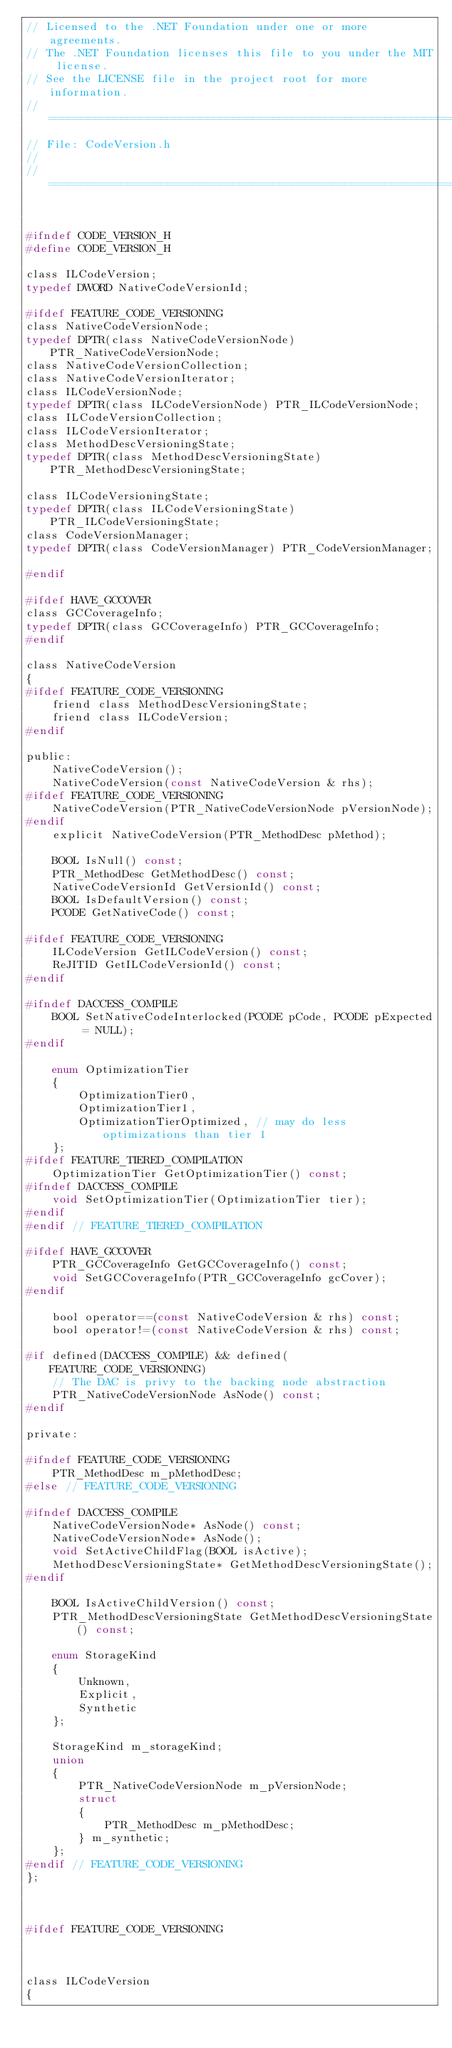<code> <loc_0><loc_0><loc_500><loc_500><_C_>// Licensed to the .NET Foundation under one or more agreements.
// The .NET Foundation licenses this file to you under the MIT license.
// See the LICENSE file in the project root for more information.
// ===========================================================================
// File: CodeVersion.h
//
// ===========================================================================


#ifndef CODE_VERSION_H
#define CODE_VERSION_H

class ILCodeVersion;
typedef DWORD NativeCodeVersionId;

#ifdef FEATURE_CODE_VERSIONING
class NativeCodeVersionNode;
typedef DPTR(class NativeCodeVersionNode) PTR_NativeCodeVersionNode;
class NativeCodeVersionCollection;
class NativeCodeVersionIterator;
class ILCodeVersionNode;
typedef DPTR(class ILCodeVersionNode) PTR_ILCodeVersionNode;
class ILCodeVersionCollection;
class ILCodeVersionIterator;
class MethodDescVersioningState;
typedef DPTR(class MethodDescVersioningState) PTR_MethodDescVersioningState;

class ILCodeVersioningState;
typedef DPTR(class ILCodeVersioningState) PTR_ILCodeVersioningState;
class CodeVersionManager;
typedef DPTR(class CodeVersionManager) PTR_CodeVersionManager;

#endif

#ifdef HAVE_GCCOVER
class GCCoverageInfo;
typedef DPTR(class GCCoverageInfo) PTR_GCCoverageInfo;
#endif

class NativeCodeVersion
{
#ifdef FEATURE_CODE_VERSIONING
    friend class MethodDescVersioningState;
    friend class ILCodeVersion;
#endif

public:
    NativeCodeVersion();
    NativeCodeVersion(const NativeCodeVersion & rhs);
#ifdef FEATURE_CODE_VERSIONING
    NativeCodeVersion(PTR_NativeCodeVersionNode pVersionNode);
#endif
    explicit NativeCodeVersion(PTR_MethodDesc pMethod);

    BOOL IsNull() const;
    PTR_MethodDesc GetMethodDesc() const;
    NativeCodeVersionId GetVersionId() const;
    BOOL IsDefaultVersion() const;
    PCODE GetNativeCode() const;

#ifdef FEATURE_CODE_VERSIONING
    ILCodeVersion GetILCodeVersion() const;
    ReJITID GetILCodeVersionId() const;
#endif

#ifndef DACCESS_COMPILE
    BOOL SetNativeCodeInterlocked(PCODE pCode, PCODE pExpected = NULL);
#endif

    enum OptimizationTier
    {
        OptimizationTier0,
        OptimizationTier1,
        OptimizationTierOptimized, // may do less optimizations than tier 1
    };
#ifdef FEATURE_TIERED_COMPILATION
    OptimizationTier GetOptimizationTier() const;
#ifndef DACCESS_COMPILE
    void SetOptimizationTier(OptimizationTier tier);
#endif
#endif // FEATURE_TIERED_COMPILATION

#ifdef HAVE_GCCOVER
    PTR_GCCoverageInfo GetGCCoverageInfo() const;
    void SetGCCoverageInfo(PTR_GCCoverageInfo gcCover);
#endif

    bool operator==(const NativeCodeVersion & rhs) const;
    bool operator!=(const NativeCodeVersion & rhs) const;

#if defined(DACCESS_COMPILE) && defined(FEATURE_CODE_VERSIONING)
    // The DAC is privy to the backing node abstraction
    PTR_NativeCodeVersionNode AsNode() const;
#endif

private:

#ifndef FEATURE_CODE_VERSIONING
    PTR_MethodDesc m_pMethodDesc;
#else // FEATURE_CODE_VERSIONING

#ifndef DACCESS_COMPILE
    NativeCodeVersionNode* AsNode() const;
    NativeCodeVersionNode* AsNode();
    void SetActiveChildFlag(BOOL isActive);
    MethodDescVersioningState* GetMethodDescVersioningState();
#endif

    BOOL IsActiveChildVersion() const;
    PTR_MethodDescVersioningState GetMethodDescVersioningState() const;

    enum StorageKind
    {
        Unknown,
        Explicit,
        Synthetic
    };

    StorageKind m_storageKind;
    union
    {
        PTR_NativeCodeVersionNode m_pVersionNode;
        struct
        {
            PTR_MethodDesc m_pMethodDesc;
        } m_synthetic;
    };
#endif // FEATURE_CODE_VERSIONING
};



#ifdef FEATURE_CODE_VERSIONING



class ILCodeVersion
{</code> 